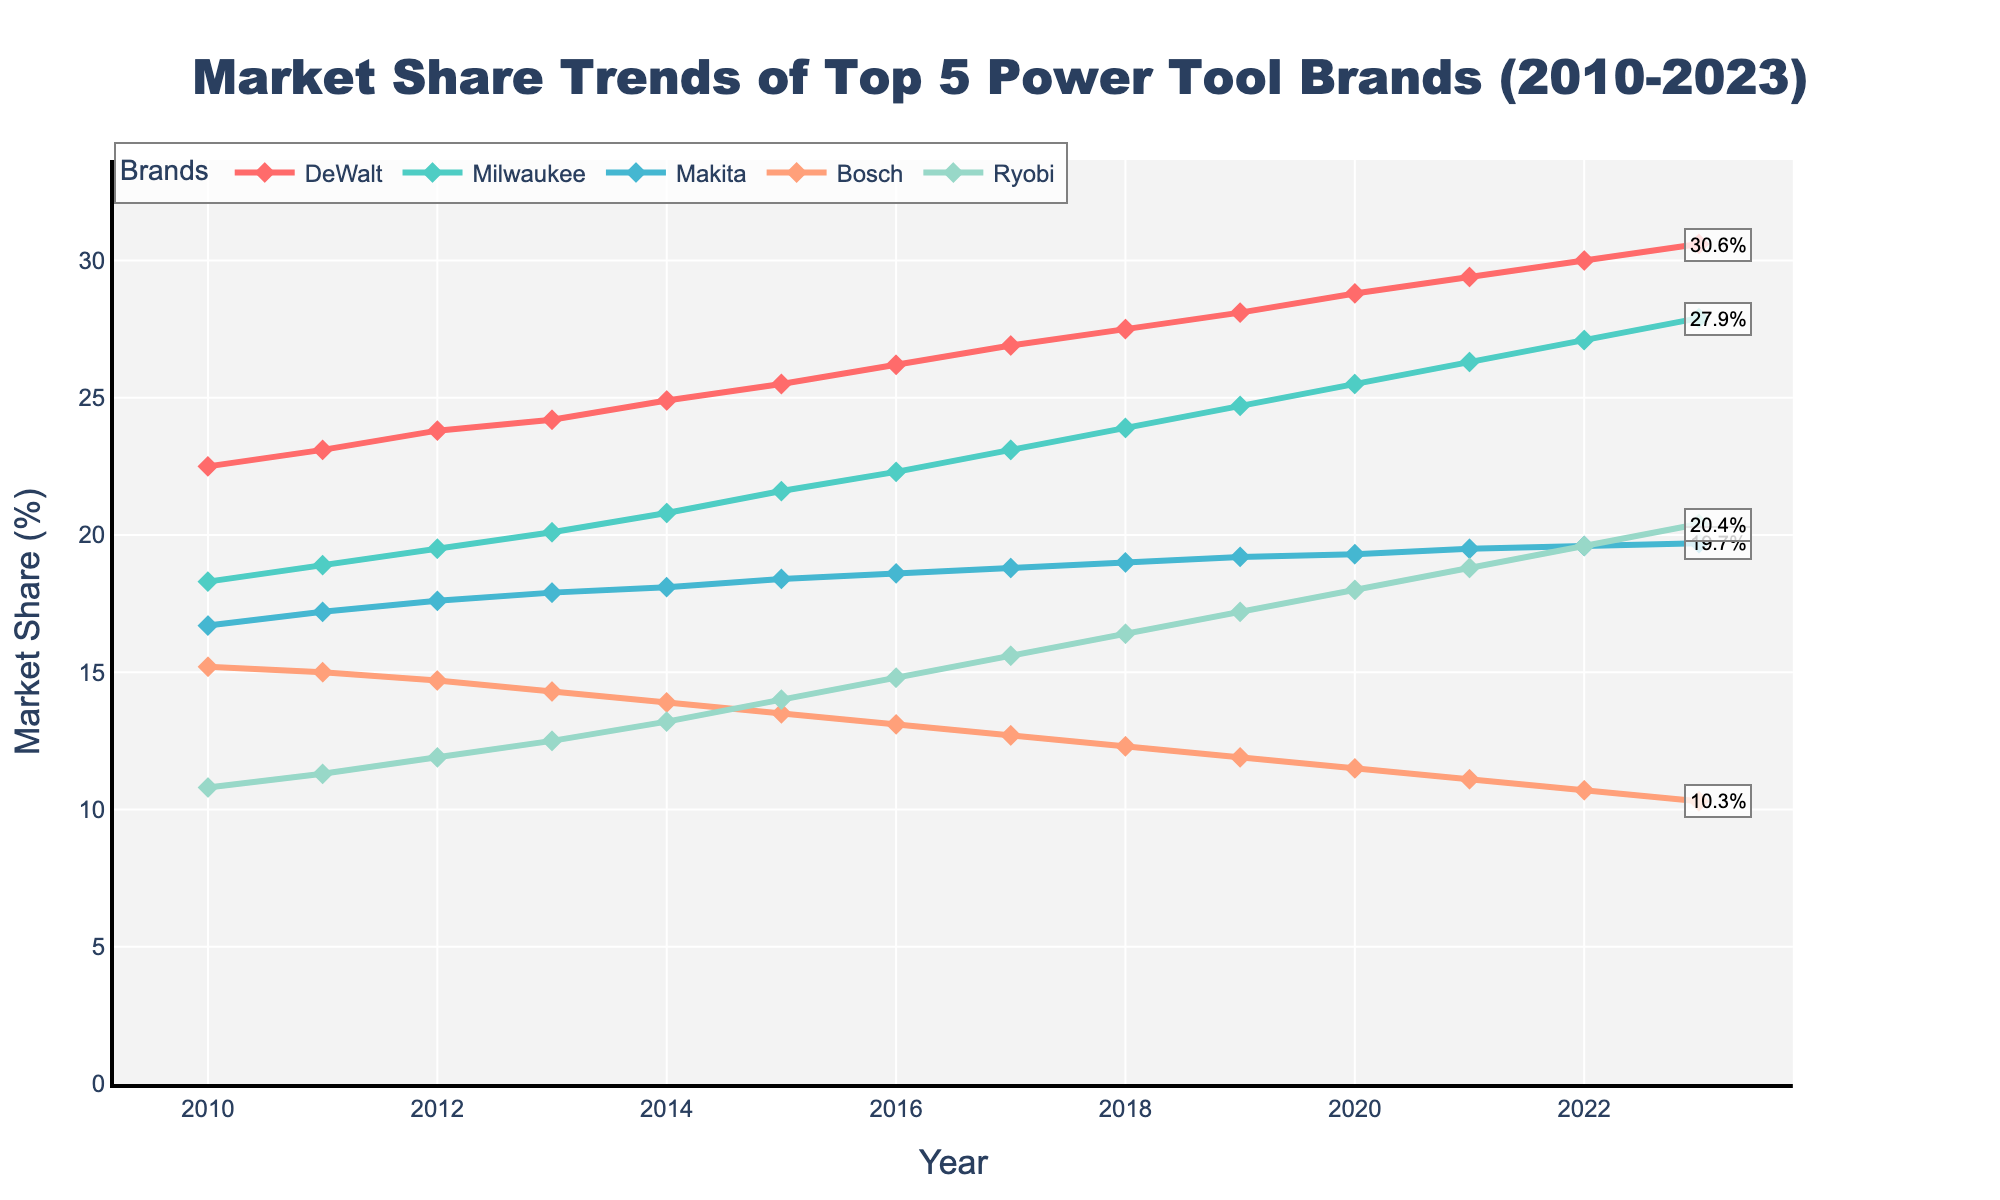What's the overall trend of DeWalt's market share from 2010 to 2023? DeWalt's market share shows a steady upward trend. Starting at 22.5% in 2010, it climbs consistently every year, reaching 30.6% in 2023.
Answer: Upward trend Which brand had the highest increase in market share from 2010 to 2023? To find the highest increase, calculate the difference in market share from 2023 and 2010 for each brand. DeWalt's increase is 30.6% - 22.5% = 8.1%. Milwaukee's increase is 27.9% - 18.3% = 9.6%. Makita's increase is 19.7% - 16.7% = 3%. Bosch's increase is 10.3% - 15.2% = -4.9%. Ryobi's increase is 20.4% - 10.8% = 9.6%. The highest increases are for Milwaukee and Ryobi, both at 9.6%.
Answer: Milwaukee and Ryobi By how much did Milwaukee's market share grow between 2015 and 2020? Milwaukee's market share in 2015 was 21.6%, and in 2020 it was 25.5%. The growth is 25.5% - 21.6% = 3.9%.
Answer: 3.9% Compare Ryobi’s market share in 2014 to DeWalt’s market share in 2014. Which one was greater and by how much? In 2014, Ryobi's market share was 13.2% and DeWalt's was 24.9%. DeWalt's share was greater by 24.9% - 13.2% = 11.7%.
Answer: DeWalt by 11.7% What is the average market share for Makita from 2010 to 2023? Sum the market shares of Makita from 2010 to 2023 and divide by the number of years. (16.7+17.2+17.6+17.9+18.1+18.4+18.6+18.8+19.0+19.2+19.3+19.5+19.6+19.7)/14 = 18.6%
Answer: 18.6% Identify the brand with the least market share in 2023. In 2023, Bosch has the least market share at 10.3%.
Answer: Bosch What is the difference between Bosch’s market share in 2010 and 2023? Bosch's market share in 2010 was 15.2%, and in 2023 it was 10.3%. The difference is 15.2% - 10.3% = 4.9%.
Answer: 4.9% How has Ryobi’s market share changed from 2010 to 2023? Ryobi's market share shows a consistent upward trend starting from 10.8% in 2010 and increasing to 20.4% in 2023.
Answer: Increased Which brand's market share plateaued the most from 2015-2020? To determine this, observe the slopes from 2015-2020 for all brands. Makita's market share shows minimal changes, from 18.4% in 2015 to 19.3% in 2020, indicating the least variation or a plateau.
Answer: Makita What is the range of market share values for Bosch from 2010 to 2023? The range is the difference between the maximum and minimum values of Bosch's market share. Bosch's values range from a high of 15.2% in 2010 to a low of 10.3% in 2023. The range is 15.2% - 10.3% = 4.9%.
Answer: 4.9% 